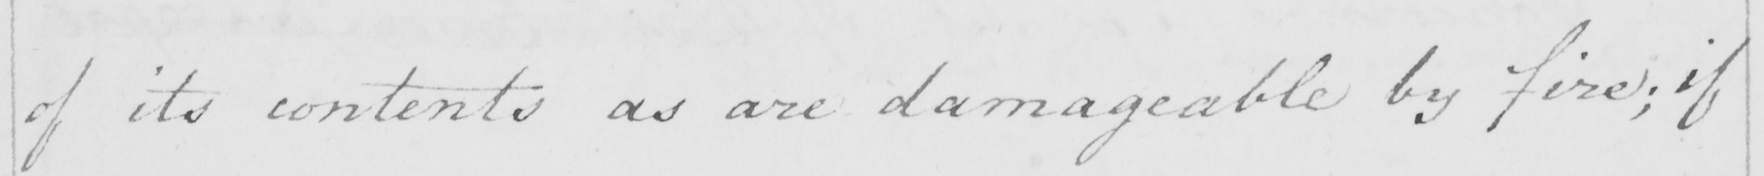Transcribe the text shown in this historical manuscript line. of its contents as are damageable by fire ; if 